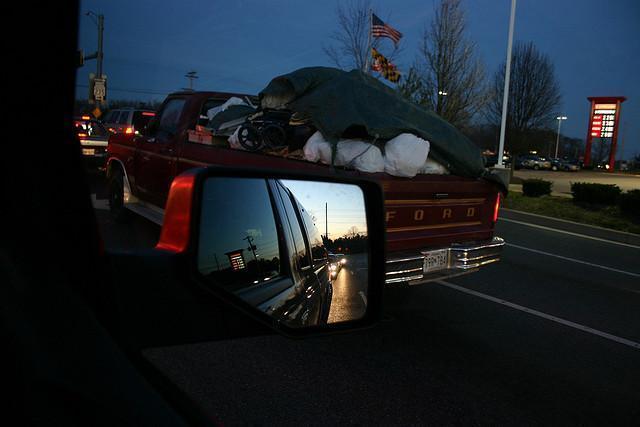How many trucks can be seen?
Give a very brief answer. 1. How many cars can be seen?
Give a very brief answer. 1. How many people are in the water?
Give a very brief answer. 0. 